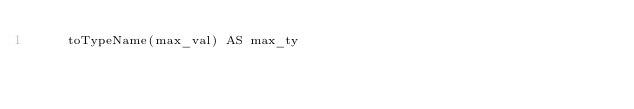<code> <loc_0><loc_0><loc_500><loc_500><_SQL_>    toTypeName(max_val) AS max_ty
</code> 